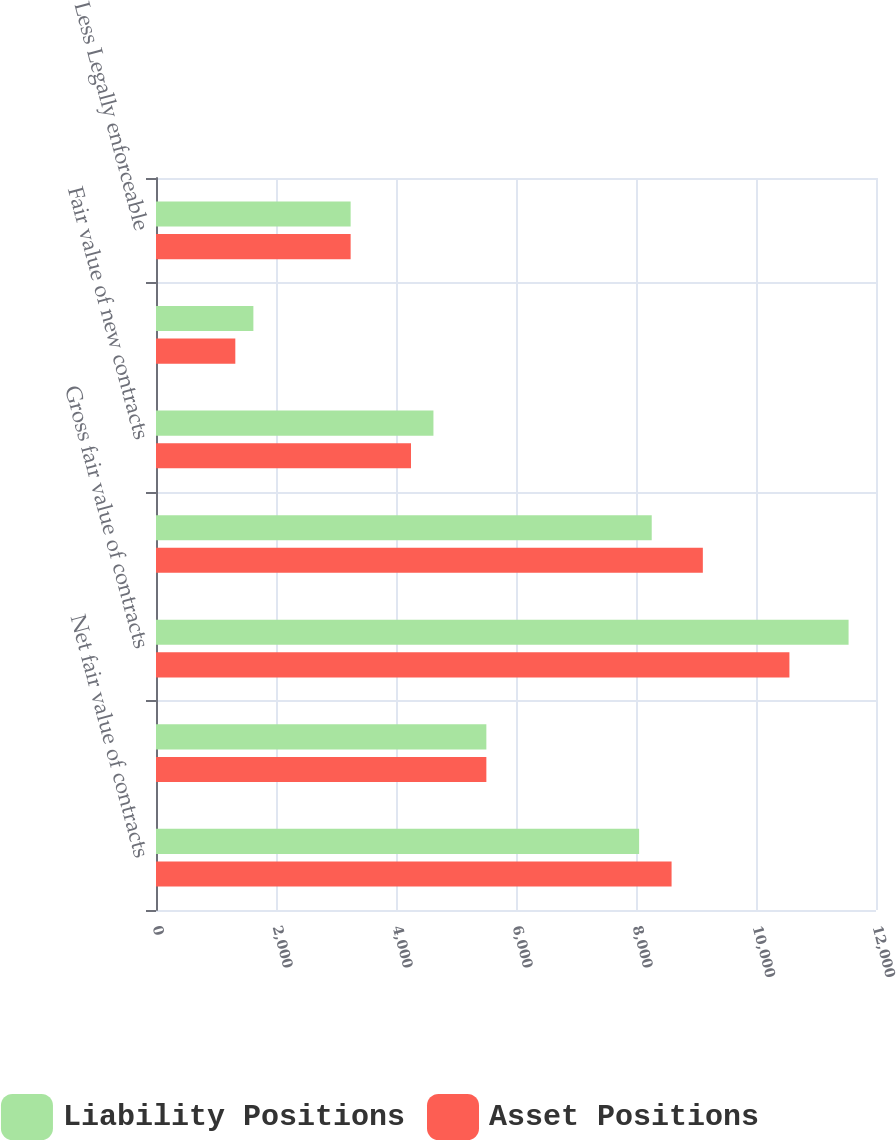Convert chart. <chart><loc_0><loc_0><loc_500><loc_500><stacked_bar_chart><ecel><fcel>Net fair value of contracts<fcel>Effect of legally enforceable<fcel>Gross fair value of contracts<fcel>Contracts realized or<fcel>Fair value of new contracts<fcel>Other changes in fair value<fcel>Less Legally enforceable<nl><fcel>Liability Positions<fcel>8052<fcel>5506<fcel>11543<fcel>8262<fcel>4624<fcel>1623<fcel>3244<nl><fcel>Asset Positions<fcel>8593<fcel>5506<fcel>10557<fcel>9114<fcel>4250<fcel>1322<fcel>3244<nl></chart> 